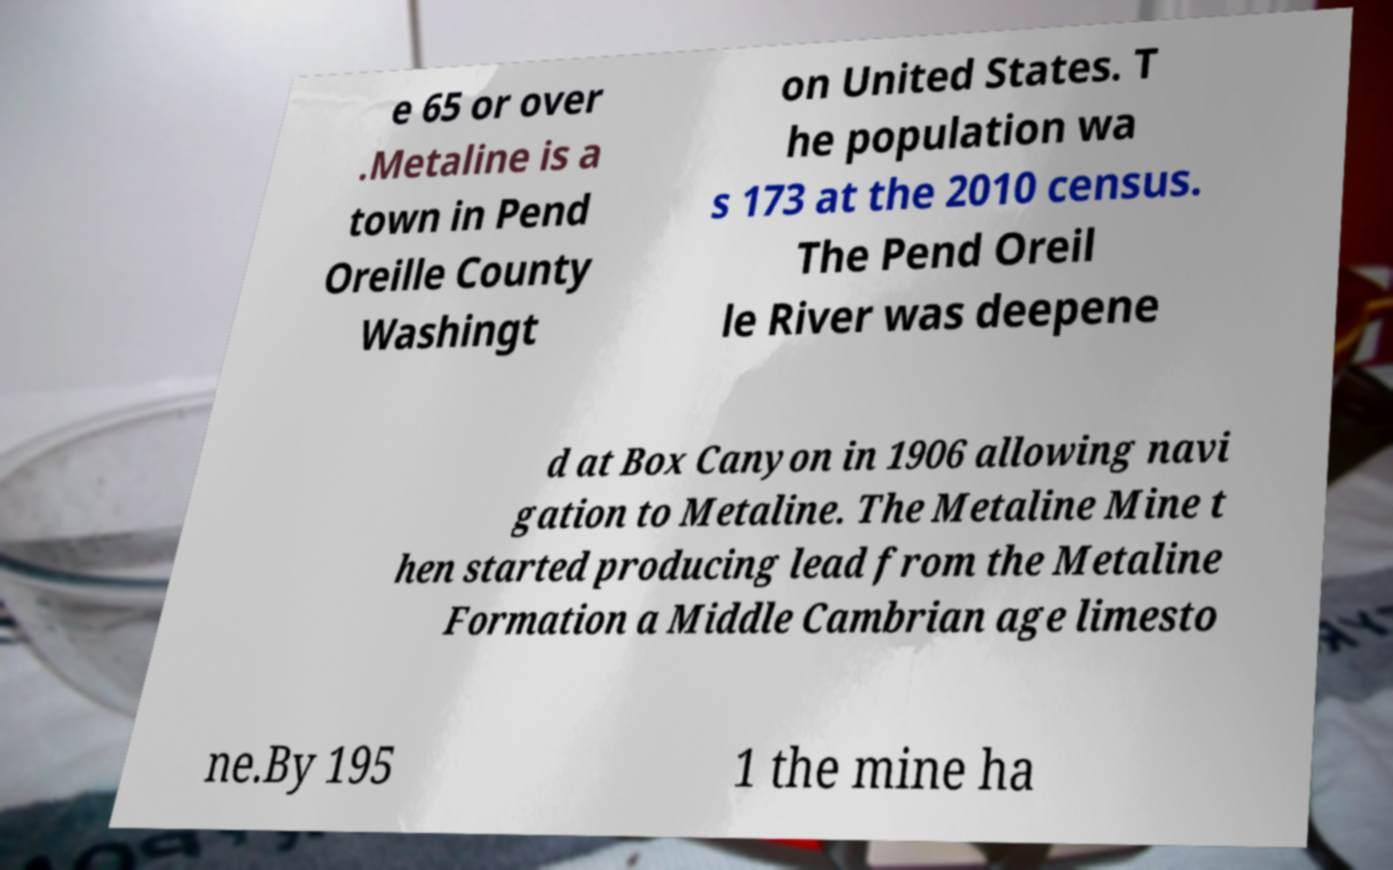Could you extract and type out the text from this image? e 65 or over .Metaline is a town in Pend Oreille County Washingt on United States. T he population wa s 173 at the 2010 census. The Pend Oreil le River was deepene d at Box Canyon in 1906 allowing navi gation to Metaline. The Metaline Mine t hen started producing lead from the Metaline Formation a Middle Cambrian age limesto ne.By 195 1 the mine ha 